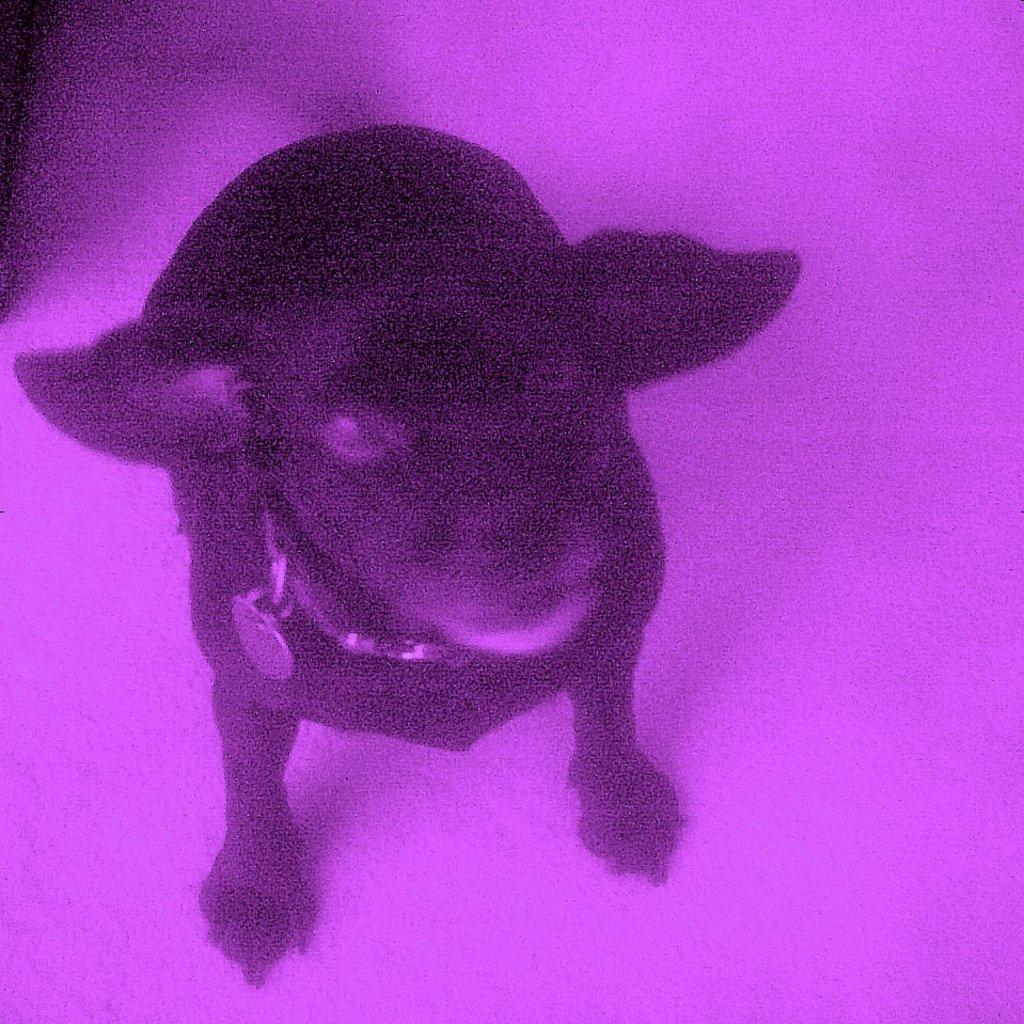What type of animal is present in the image? There is an animal in the image. Can you describe the position of the animal in the image? The animal is standing on the floor. How is the animal being restrained in the image? The animal is tied with a belt. What activity is the animal participating in the image? The image does not depict any specific activity involving the animal. 